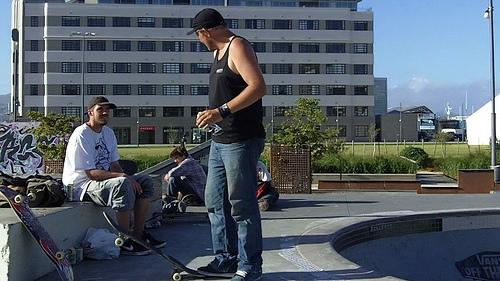How many skateboards are visible in the image? 3 skateboards. Describe the two men who are wearing hats in the image. One man wears a black baseball hat while standing on a skateboard, and another man sits on a bench wearing a black hat. What brand of shoes is the skateboarder wearing? Nike. What is the white object on the ground next to the skateboard? A white bag. What is the predominant color of the graffiti on the wall? Black, purple, and blue. List the objects that are leaning against the concrete wall. A skateboard with white wheels and a white bag. What is the main activity taking place in the image? Skateboarding. How many windows on the buildings can be seen in the image? 6 windows. Describe the area surrounding the skateboard park. Grey colored concrete, large metal poles with streetlights, tall grey and white buildings, and a fence in the background. Can you identify any pieces of clothing or accessories on the man on the skateboard? He is wearing a black tank top and has a black band on his wrist. Can you spot a small sleeping kitten next to the skateboard with white wheels leaning against the concrete wall? No, it's not mentioned in the image. What type of footwear is the person with black and white shoes wearing? Nike shoes Describe the scene in a simple sentence. People with skateboards in a skatepark with graffiti and buildings in the background. What type of building is in the background? Tall grey and white building What brand logo is present on the black and white shoes? Nike Which activity is the man in black shirt performing? Skateboarding How would you describe the area where the skateboarders are? Grey colored concrete skateboard park Which object is slanted upwards in the image? Skateboard What type of shirt is the young man at the back wearing? Plaid shirt What is the fence in the background made of? Brown metal What is the object leaning against the concrete wall next to the skateboard? White bag Describe the sitting man's appearance. Young man wearing a white shirt, jean shorts, black hat, and Nike shoes. Is there windows on a building? Yes What is the color of the graffiti on the wall? Black, purple, and blue Find the elderly lady wearing a red dress walking across the grey colored concrete around the skateboard park. Is she visible? There is no mention of an elderly lady, red dress, or anyone walking in the image. Introducing a new character that doesn't exist in the image will create confusion for the viewer. Is the man wearing a white shirt sitting or standing? Sitting Count the total number of skateboard wheels visible in the image. 8 What is the color of the cap worn by the sitting young man? Black How many skateboarders are visible in the image? 2 What color is the shirt of the young man with jean shorts? White What is the purpose of the large metal poles in the image? Streetlights 